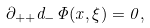<formula> <loc_0><loc_0><loc_500><loc_500>\partial _ { + + } d _ { - } \Phi ( x , \xi ) = 0 ,</formula> 